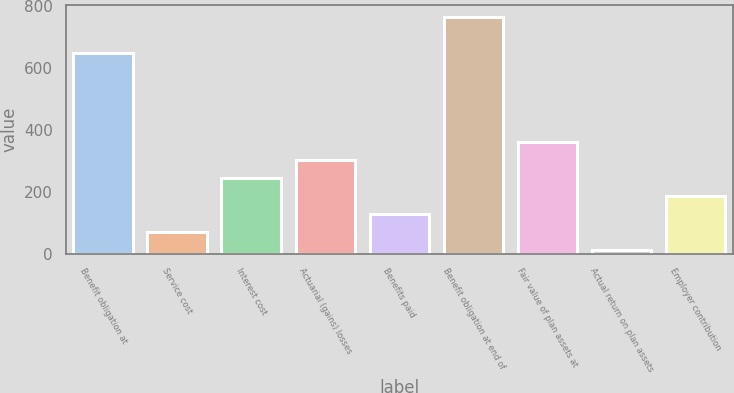<chart> <loc_0><loc_0><loc_500><loc_500><bar_chart><fcel>Benefit obligation at<fcel>Service cost<fcel>Interest cost<fcel>Actuarial (gains) losses<fcel>Benefits paid<fcel>Benefit obligation at end of<fcel>Fair value of plan assets at<fcel>Actual return on plan assets<fcel>Employer contribution<nl><fcel>650<fcel>70<fcel>244<fcel>302<fcel>128<fcel>766<fcel>360<fcel>12<fcel>186<nl></chart> 